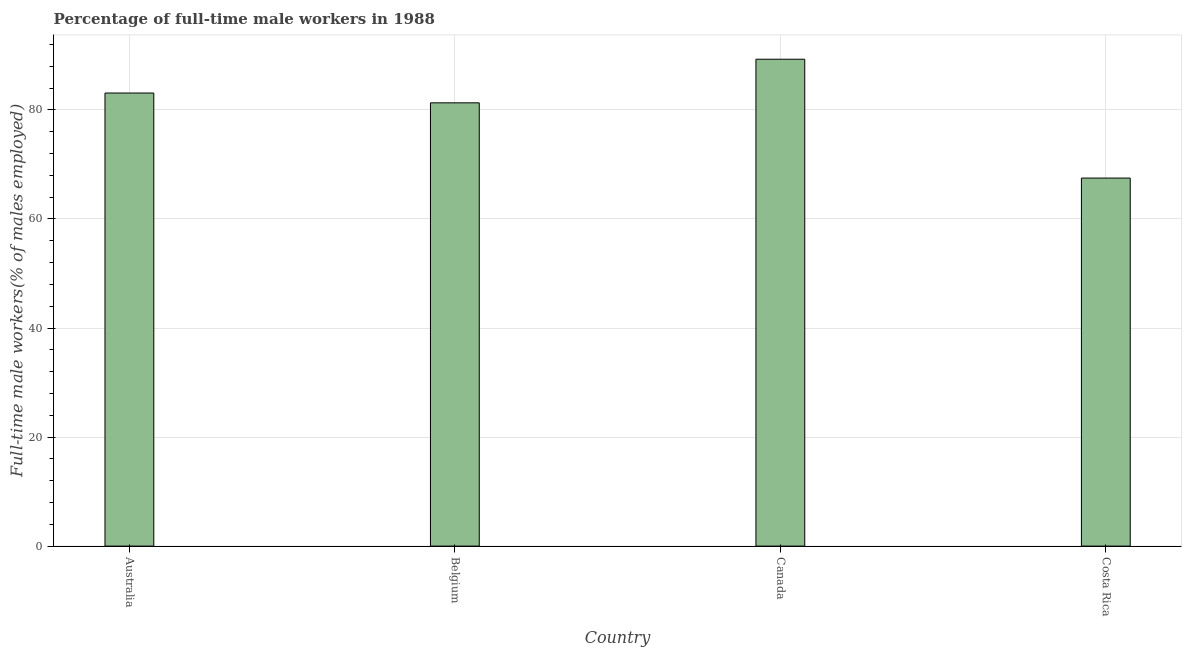What is the title of the graph?
Offer a very short reply. Percentage of full-time male workers in 1988. What is the label or title of the X-axis?
Your response must be concise. Country. What is the label or title of the Y-axis?
Your response must be concise. Full-time male workers(% of males employed). What is the percentage of full-time male workers in Australia?
Your response must be concise. 83.1. Across all countries, what is the maximum percentage of full-time male workers?
Your response must be concise. 89.3. Across all countries, what is the minimum percentage of full-time male workers?
Your answer should be compact. 67.5. In which country was the percentage of full-time male workers maximum?
Give a very brief answer. Canada. What is the sum of the percentage of full-time male workers?
Offer a very short reply. 321.2. What is the average percentage of full-time male workers per country?
Give a very brief answer. 80.3. What is the median percentage of full-time male workers?
Make the answer very short. 82.2. What is the difference between the highest and the second highest percentage of full-time male workers?
Make the answer very short. 6.2. What is the difference between the highest and the lowest percentage of full-time male workers?
Ensure brevity in your answer.  21.8. In how many countries, is the percentage of full-time male workers greater than the average percentage of full-time male workers taken over all countries?
Your answer should be very brief. 3. How many countries are there in the graph?
Offer a very short reply. 4. What is the Full-time male workers(% of males employed) in Australia?
Offer a very short reply. 83.1. What is the Full-time male workers(% of males employed) in Belgium?
Offer a very short reply. 81.3. What is the Full-time male workers(% of males employed) in Canada?
Offer a very short reply. 89.3. What is the Full-time male workers(% of males employed) in Costa Rica?
Offer a terse response. 67.5. What is the difference between the Full-time male workers(% of males employed) in Australia and Costa Rica?
Keep it short and to the point. 15.6. What is the difference between the Full-time male workers(% of males employed) in Belgium and Canada?
Offer a very short reply. -8. What is the difference between the Full-time male workers(% of males employed) in Canada and Costa Rica?
Make the answer very short. 21.8. What is the ratio of the Full-time male workers(% of males employed) in Australia to that in Belgium?
Provide a short and direct response. 1.02. What is the ratio of the Full-time male workers(% of males employed) in Australia to that in Costa Rica?
Provide a succinct answer. 1.23. What is the ratio of the Full-time male workers(% of males employed) in Belgium to that in Canada?
Provide a succinct answer. 0.91. What is the ratio of the Full-time male workers(% of males employed) in Belgium to that in Costa Rica?
Your answer should be compact. 1.2. What is the ratio of the Full-time male workers(% of males employed) in Canada to that in Costa Rica?
Your answer should be very brief. 1.32. 